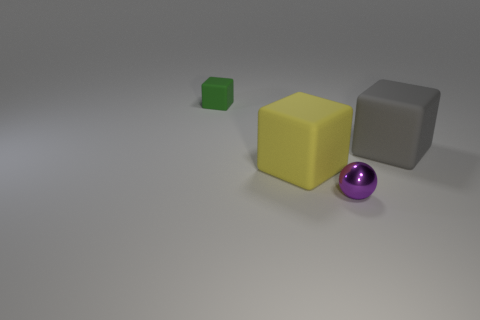Are there any gray rubber cubes behind the large yellow rubber thing?
Offer a very short reply. Yes. Are the small object that is in front of the green block and the large cube to the left of the large gray rubber object made of the same material?
Give a very brief answer. No. Are there fewer green objects left of the large yellow block than big gray rubber cylinders?
Provide a succinct answer. No. What color is the tiny object left of the big yellow matte object?
Provide a short and direct response. Green. There is a large cube on the right side of the big cube to the left of the gray rubber object; what is it made of?
Give a very brief answer. Rubber. Are there any yellow objects of the same size as the green matte cube?
Your answer should be compact. No. How many objects are cubes on the right side of the large yellow rubber cube or objects that are on the right side of the small green matte thing?
Your answer should be compact. 3. Is the size of the green thing that is behind the small purple shiny ball the same as the rubber object right of the big yellow block?
Ensure brevity in your answer.  No. There is a large cube on the left side of the purple metallic sphere; are there any small matte cubes behind it?
Your answer should be compact. Yes. There is a yellow matte object; how many cubes are behind it?
Offer a terse response. 2. 